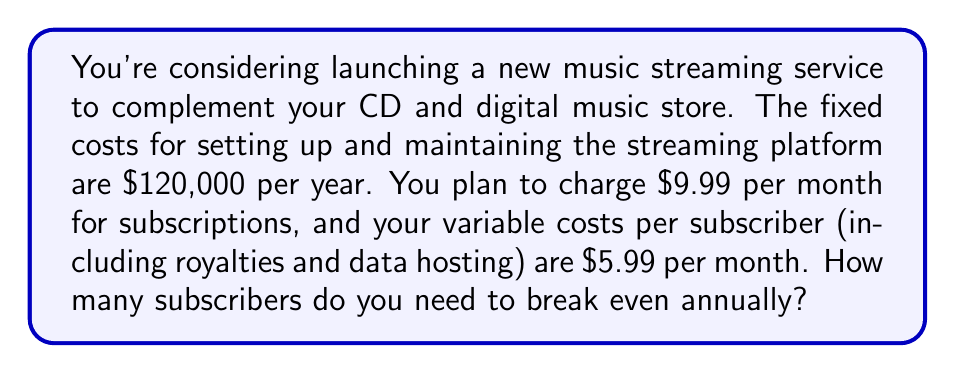Show me your answer to this math problem. To solve this problem, we need to determine the break-even point where total revenue equals total costs. Let's break it down step-by-step:

1. Define variables:
   Let $x$ be the number of subscribers needed to break even annually.

2. Calculate annual revenue per subscriber:
   Monthly revenue per subscriber = $9.99
   Annual revenue per subscriber = $9.99 \times 12 = $119.88

3. Calculate annual variable costs per subscriber:
   Monthly variable costs per subscriber = $5.99
   Annual variable costs per subscriber = $5.99 \times 12 = $71.88

4. Set up the break-even equation:
   Total Revenue = Total Costs
   $119.88x = 120,000 + 71.88x$

5. Solve for $x$:
   $$\begin{align}
   119.88x &= 120,000 + 71.88x \\
   119.88x - 71.88x &= 120,000 \\
   48x &= 120,000 \\
   x &= \frac{120,000}{48} \\
   x &= 2,500
   \end{align}$$

Therefore, you need 2,500 subscribers to break even annually.

To verify:
Annual Revenue = $119.88 \times 2,500 = $299,700
Annual Costs = $120,000 + ($71.88 \times 2,500) = $299,700

This confirms that at 2,500 subscribers, total revenue equals total costs.
Answer: 2,500 subscribers 